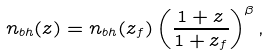Convert formula to latex. <formula><loc_0><loc_0><loc_500><loc_500>n _ { b h } ( z ) = n _ { b h } ( z _ { f } ) \left ( \frac { 1 + z } { 1 + z _ { f } } \right ) ^ { \beta } ,</formula> 